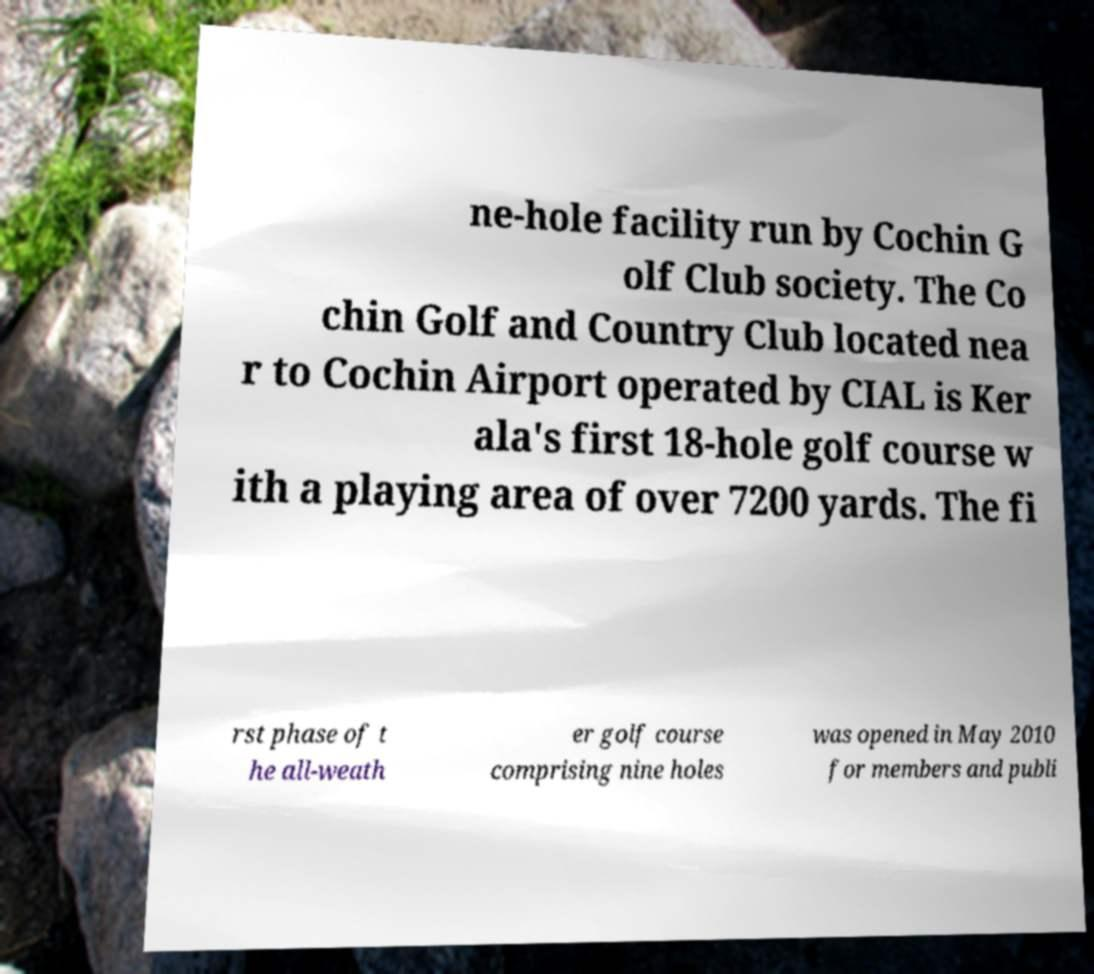For documentation purposes, I need the text within this image transcribed. Could you provide that? ne-hole facility run by Cochin G olf Club society. The Co chin Golf and Country Club located nea r to Cochin Airport operated by CIAL is Ker ala's first 18-hole golf course w ith a playing area of over 7200 yards. The fi rst phase of t he all-weath er golf course comprising nine holes was opened in May 2010 for members and publi 